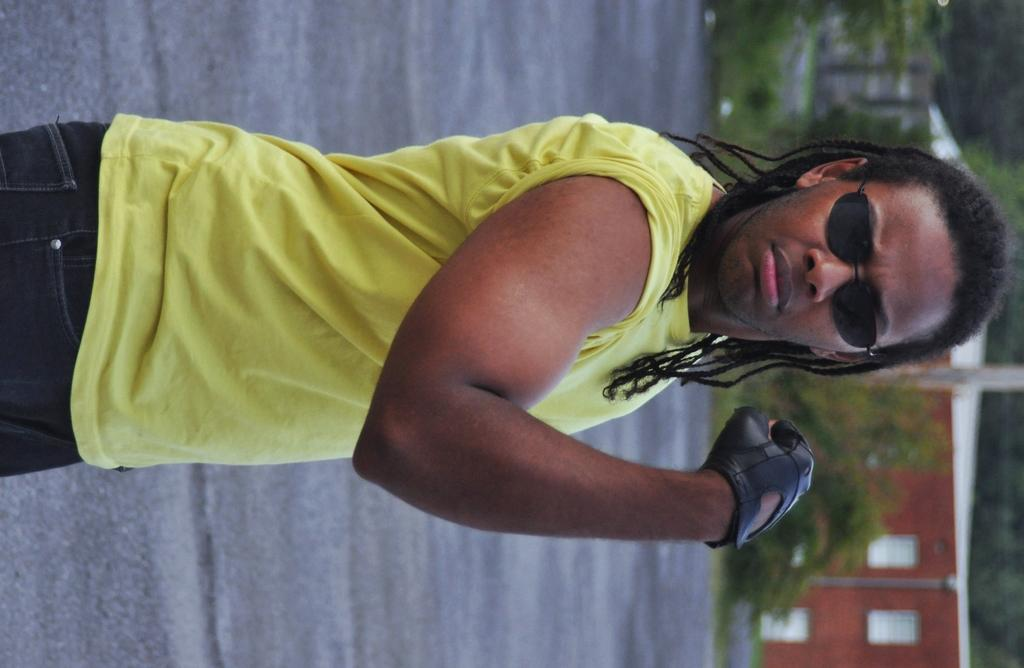Who is present in the image? There is a man in the picture. What is the man wearing in the image? The man is wearing sunglasses. What type of structure can be seen in the image? There is a building in the image. What type of vegetation is present in the image? There are trees in the image. What type of card is the man holding in the image? There is no card present in the image; the man is only wearing sunglasses. What type of truck can be seen driving past the building in the image? There is no truck visible in the image; only the man, building, and trees are present. 